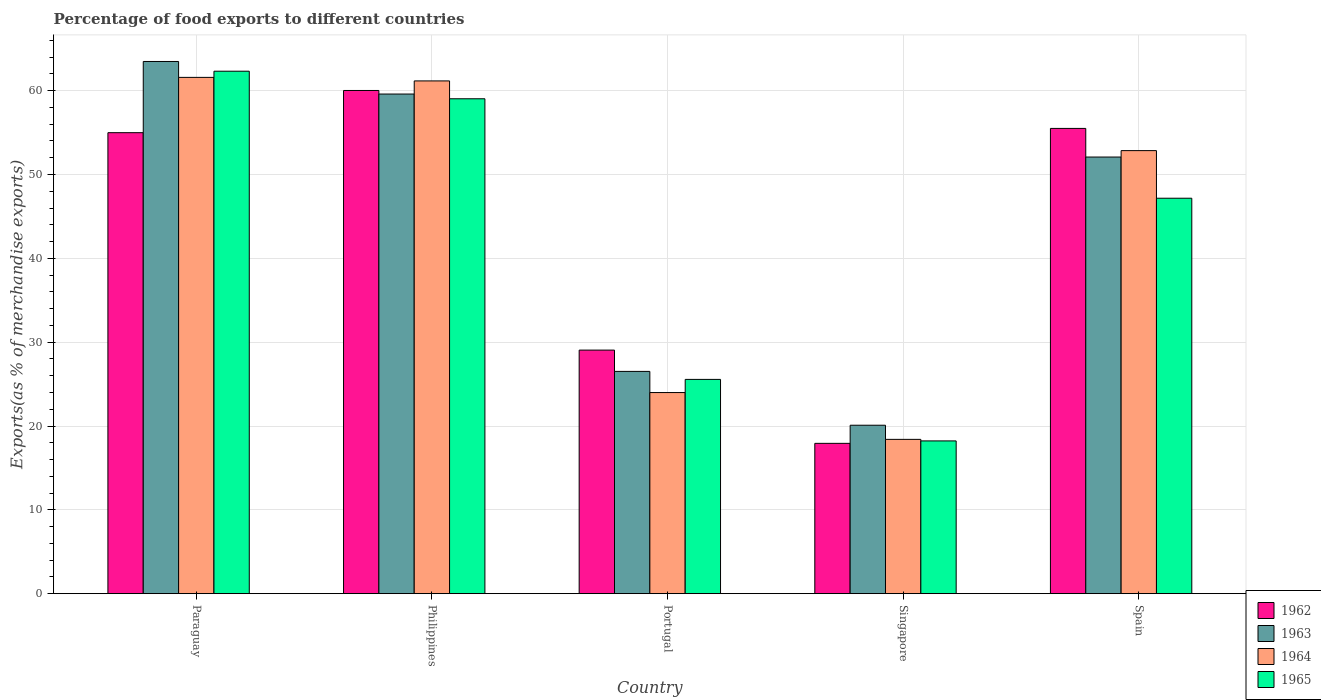How many different coloured bars are there?
Your answer should be compact. 4. How many groups of bars are there?
Give a very brief answer. 5. Are the number of bars per tick equal to the number of legend labels?
Your answer should be compact. Yes. Are the number of bars on each tick of the X-axis equal?
Offer a very short reply. Yes. What is the percentage of exports to different countries in 1965 in Philippines?
Your answer should be very brief. 59.04. Across all countries, what is the maximum percentage of exports to different countries in 1965?
Your answer should be compact. 62.32. Across all countries, what is the minimum percentage of exports to different countries in 1963?
Give a very brief answer. 20.09. In which country was the percentage of exports to different countries in 1965 maximum?
Provide a short and direct response. Paraguay. In which country was the percentage of exports to different countries in 1965 minimum?
Provide a succinct answer. Singapore. What is the total percentage of exports to different countries in 1963 in the graph?
Offer a terse response. 221.78. What is the difference between the percentage of exports to different countries in 1963 in Paraguay and that in Spain?
Offer a very short reply. 11.4. What is the difference between the percentage of exports to different countries in 1965 in Singapore and the percentage of exports to different countries in 1963 in Portugal?
Your answer should be very brief. -8.29. What is the average percentage of exports to different countries in 1965 per country?
Give a very brief answer. 42.46. What is the difference between the percentage of exports to different countries of/in 1965 and percentage of exports to different countries of/in 1964 in Philippines?
Make the answer very short. -2.13. What is the ratio of the percentage of exports to different countries in 1963 in Portugal to that in Singapore?
Your response must be concise. 1.32. What is the difference between the highest and the second highest percentage of exports to different countries in 1963?
Ensure brevity in your answer.  7.52. What is the difference between the highest and the lowest percentage of exports to different countries in 1962?
Give a very brief answer. 42.1. In how many countries, is the percentage of exports to different countries in 1962 greater than the average percentage of exports to different countries in 1962 taken over all countries?
Provide a succinct answer. 3. Is the sum of the percentage of exports to different countries in 1962 in Philippines and Singapore greater than the maximum percentage of exports to different countries in 1963 across all countries?
Keep it short and to the point. Yes. Is it the case that in every country, the sum of the percentage of exports to different countries in 1963 and percentage of exports to different countries in 1962 is greater than the sum of percentage of exports to different countries in 1965 and percentage of exports to different countries in 1964?
Provide a succinct answer. No. What does the 3rd bar from the left in Singapore represents?
Provide a short and direct response. 1964. What does the 3rd bar from the right in Philippines represents?
Offer a very short reply. 1963. How many countries are there in the graph?
Your response must be concise. 5. What is the difference between two consecutive major ticks on the Y-axis?
Offer a very short reply. 10. Are the values on the major ticks of Y-axis written in scientific E-notation?
Make the answer very short. No. Does the graph contain grids?
Make the answer very short. Yes. What is the title of the graph?
Your answer should be compact. Percentage of food exports to different countries. What is the label or title of the Y-axis?
Offer a terse response. Exports(as % of merchandise exports). What is the Exports(as % of merchandise exports) of 1962 in Paraguay?
Offer a very short reply. 54.99. What is the Exports(as % of merchandise exports) in 1963 in Paraguay?
Ensure brevity in your answer.  63.48. What is the Exports(as % of merchandise exports) of 1964 in Paraguay?
Keep it short and to the point. 61.59. What is the Exports(as % of merchandise exports) in 1965 in Paraguay?
Your answer should be compact. 62.32. What is the Exports(as % of merchandise exports) in 1962 in Philippines?
Provide a succinct answer. 60.03. What is the Exports(as % of merchandise exports) of 1963 in Philippines?
Provide a succinct answer. 59.6. What is the Exports(as % of merchandise exports) of 1964 in Philippines?
Provide a short and direct response. 61.17. What is the Exports(as % of merchandise exports) of 1965 in Philippines?
Offer a terse response. 59.04. What is the Exports(as % of merchandise exports) of 1962 in Portugal?
Provide a succinct answer. 29.05. What is the Exports(as % of merchandise exports) in 1963 in Portugal?
Ensure brevity in your answer.  26.51. What is the Exports(as % of merchandise exports) of 1964 in Portugal?
Provide a succinct answer. 23.99. What is the Exports(as % of merchandise exports) of 1965 in Portugal?
Make the answer very short. 25.56. What is the Exports(as % of merchandise exports) of 1962 in Singapore?
Give a very brief answer. 17.93. What is the Exports(as % of merchandise exports) of 1963 in Singapore?
Provide a short and direct response. 20.09. What is the Exports(as % of merchandise exports) in 1964 in Singapore?
Your answer should be compact. 18.41. What is the Exports(as % of merchandise exports) of 1965 in Singapore?
Your answer should be very brief. 18.22. What is the Exports(as % of merchandise exports) in 1962 in Spain?
Your answer should be very brief. 55.5. What is the Exports(as % of merchandise exports) in 1963 in Spain?
Your answer should be very brief. 52.09. What is the Exports(as % of merchandise exports) of 1964 in Spain?
Keep it short and to the point. 52.85. What is the Exports(as % of merchandise exports) of 1965 in Spain?
Offer a very short reply. 47.17. Across all countries, what is the maximum Exports(as % of merchandise exports) of 1962?
Your response must be concise. 60.03. Across all countries, what is the maximum Exports(as % of merchandise exports) in 1963?
Your answer should be compact. 63.48. Across all countries, what is the maximum Exports(as % of merchandise exports) in 1964?
Offer a terse response. 61.59. Across all countries, what is the maximum Exports(as % of merchandise exports) in 1965?
Make the answer very short. 62.32. Across all countries, what is the minimum Exports(as % of merchandise exports) of 1962?
Your answer should be compact. 17.93. Across all countries, what is the minimum Exports(as % of merchandise exports) of 1963?
Make the answer very short. 20.09. Across all countries, what is the minimum Exports(as % of merchandise exports) of 1964?
Make the answer very short. 18.41. Across all countries, what is the minimum Exports(as % of merchandise exports) in 1965?
Give a very brief answer. 18.22. What is the total Exports(as % of merchandise exports) of 1962 in the graph?
Give a very brief answer. 217.5. What is the total Exports(as % of merchandise exports) of 1963 in the graph?
Give a very brief answer. 221.78. What is the total Exports(as % of merchandise exports) of 1964 in the graph?
Provide a succinct answer. 218. What is the total Exports(as % of merchandise exports) of 1965 in the graph?
Provide a short and direct response. 212.31. What is the difference between the Exports(as % of merchandise exports) in 1962 in Paraguay and that in Philippines?
Provide a succinct answer. -5.03. What is the difference between the Exports(as % of merchandise exports) in 1963 in Paraguay and that in Philippines?
Provide a short and direct response. 3.88. What is the difference between the Exports(as % of merchandise exports) in 1964 in Paraguay and that in Philippines?
Your answer should be very brief. 0.42. What is the difference between the Exports(as % of merchandise exports) in 1965 in Paraguay and that in Philippines?
Offer a terse response. 3.29. What is the difference between the Exports(as % of merchandise exports) of 1962 in Paraguay and that in Portugal?
Your answer should be very brief. 25.94. What is the difference between the Exports(as % of merchandise exports) of 1963 in Paraguay and that in Portugal?
Ensure brevity in your answer.  36.97. What is the difference between the Exports(as % of merchandise exports) in 1964 in Paraguay and that in Portugal?
Provide a short and direct response. 37.6. What is the difference between the Exports(as % of merchandise exports) in 1965 in Paraguay and that in Portugal?
Give a very brief answer. 36.77. What is the difference between the Exports(as % of merchandise exports) of 1962 in Paraguay and that in Singapore?
Offer a very short reply. 37.06. What is the difference between the Exports(as % of merchandise exports) in 1963 in Paraguay and that in Singapore?
Offer a very short reply. 43.39. What is the difference between the Exports(as % of merchandise exports) in 1964 in Paraguay and that in Singapore?
Provide a succinct answer. 43.18. What is the difference between the Exports(as % of merchandise exports) in 1965 in Paraguay and that in Singapore?
Offer a very short reply. 44.1. What is the difference between the Exports(as % of merchandise exports) of 1962 in Paraguay and that in Spain?
Make the answer very short. -0.51. What is the difference between the Exports(as % of merchandise exports) of 1963 in Paraguay and that in Spain?
Your response must be concise. 11.4. What is the difference between the Exports(as % of merchandise exports) of 1964 in Paraguay and that in Spain?
Provide a short and direct response. 8.73. What is the difference between the Exports(as % of merchandise exports) of 1965 in Paraguay and that in Spain?
Ensure brevity in your answer.  15.15. What is the difference between the Exports(as % of merchandise exports) in 1962 in Philippines and that in Portugal?
Make the answer very short. 30.97. What is the difference between the Exports(as % of merchandise exports) of 1963 in Philippines and that in Portugal?
Ensure brevity in your answer.  33.09. What is the difference between the Exports(as % of merchandise exports) of 1964 in Philippines and that in Portugal?
Offer a terse response. 37.18. What is the difference between the Exports(as % of merchandise exports) in 1965 in Philippines and that in Portugal?
Provide a short and direct response. 33.48. What is the difference between the Exports(as % of merchandise exports) of 1962 in Philippines and that in Singapore?
Your answer should be very brief. 42.1. What is the difference between the Exports(as % of merchandise exports) in 1963 in Philippines and that in Singapore?
Your response must be concise. 39.51. What is the difference between the Exports(as % of merchandise exports) in 1964 in Philippines and that in Singapore?
Provide a succinct answer. 42.76. What is the difference between the Exports(as % of merchandise exports) of 1965 in Philippines and that in Singapore?
Provide a short and direct response. 40.81. What is the difference between the Exports(as % of merchandise exports) in 1962 in Philippines and that in Spain?
Offer a terse response. 4.53. What is the difference between the Exports(as % of merchandise exports) of 1963 in Philippines and that in Spain?
Your answer should be very brief. 7.52. What is the difference between the Exports(as % of merchandise exports) in 1964 in Philippines and that in Spain?
Keep it short and to the point. 8.31. What is the difference between the Exports(as % of merchandise exports) in 1965 in Philippines and that in Spain?
Ensure brevity in your answer.  11.86. What is the difference between the Exports(as % of merchandise exports) in 1962 in Portugal and that in Singapore?
Offer a terse response. 11.12. What is the difference between the Exports(as % of merchandise exports) of 1963 in Portugal and that in Singapore?
Provide a short and direct response. 6.42. What is the difference between the Exports(as % of merchandise exports) in 1964 in Portugal and that in Singapore?
Give a very brief answer. 5.58. What is the difference between the Exports(as % of merchandise exports) in 1965 in Portugal and that in Singapore?
Provide a succinct answer. 7.34. What is the difference between the Exports(as % of merchandise exports) in 1962 in Portugal and that in Spain?
Your answer should be compact. -26.45. What is the difference between the Exports(as % of merchandise exports) of 1963 in Portugal and that in Spain?
Provide a short and direct response. -25.57. What is the difference between the Exports(as % of merchandise exports) in 1964 in Portugal and that in Spain?
Ensure brevity in your answer.  -28.86. What is the difference between the Exports(as % of merchandise exports) in 1965 in Portugal and that in Spain?
Keep it short and to the point. -21.61. What is the difference between the Exports(as % of merchandise exports) of 1962 in Singapore and that in Spain?
Your answer should be compact. -37.57. What is the difference between the Exports(as % of merchandise exports) in 1963 in Singapore and that in Spain?
Your response must be concise. -31.99. What is the difference between the Exports(as % of merchandise exports) of 1964 in Singapore and that in Spain?
Offer a terse response. -34.45. What is the difference between the Exports(as % of merchandise exports) of 1965 in Singapore and that in Spain?
Provide a short and direct response. -28.95. What is the difference between the Exports(as % of merchandise exports) of 1962 in Paraguay and the Exports(as % of merchandise exports) of 1963 in Philippines?
Offer a very short reply. -4.61. What is the difference between the Exports(as % of merchandise exports) in 1962 in Paraguay and the Exports(as % of merchandise exports) in 1964 in Philippines?
Offer a very short reply. -6.18. What is the difference between the Exports(as % of merchandise exports) in 1962 in Paraguay and the Exports(as % of merchandise exports) in 1965 in Philippines?
Ensure brevity in your answer.  -4.04. What is the difference between the Exports(as % of merchandise exports) in 1963 in Paraguay and the Exports(as % of merchandise exports) in 1964 in Philippines?
Provide a succinct answer. 2.32. What is the difference between the Exports(as % of merchandise exports) in 1963 in Paraguay and the Exports(as % of merchandise exports) in 1965 in Philippines?
Ensure brevity in your answer.  4.45. What is the difference between the Exports(as % of merchandise exports) of 1964 in Paraguay and the Exports(as % of merchandise exports) of 1965 in Philippines?
Your answer should be compact. 2.55. What is the difference between the Exports(as % of merchandise exports) in 1962 in Paraguay and the Exports(as % of merchandise exports) in 1963 in Portugal?
Offer a very short reply. 28.48. What is the difference between the Exports(as % of merchandise exports) in 1962 in Paraguay and the Exports(as % of merchandise exports) in 1964 in Portugal?
Your answer should be very brief. 31. What is the difference between the Exports(as % of merchandise exports) in 1962 in Paraguay and the Exports(as % of merchandise exports) in 1965 in Portugal?
Keep it short and to the point. 29.43. What is the difference between the Exports(as % of merchandise exports) of 1963 in Paraguay and the Exports(as % of merchandise exports) of 1964 in Portugal?
Make the answer very short. 39.49. What is the difference between the Exports(as % of merchandise exports) of 1963 in Paraguay and the Exports(as % of merchandise exports) of 1965 in Portugal?
Provide a succinct answer. 37.93. What is the difference between the Exports(as % of merchandise exports) in 1964 in Paraguay and the Exports(as % of merchandise exports) in 1965 in Portugal?
Your answer should be compact. 36.03. What is the difference between the Exports(as % of merchandise exports) of 1962 in Paraguay and the Exports(as % of merchandise exports) of 1963 in Singapore?
Offer a terse response. 34.9. What is the difference between the Exports(as % of merchandise exports) in 1962 in Paraguay and the Exports(as % of merchandise exports) in 1964 in Singapore?
Provide a short and direct response. 36.59. What is the difference between the Exports(as % of merchandise exports) in 1962 in Paraguay and the Exports(as % of merchandise exports) in 1965 in Singapore?
Provide a short and direct response. 36.77. What is the difference between the Exports(as % of merchandise exports) of 1963 in Paraguay and the Exports(as % of merchandise exports) of 1964 in Singapore?
Your answer should be compact. 45.08. What is the difference between the Exports(as % of merchandise exports) of 1963 in Paraguay and the Exports(as % of merchandise exports) of 1965 in Singapore?
Offer a terse response. 45.26. What is the difference between the Exports(as % of merchandise exports) in 1964 in Paraguay and the Exports(as % of merchandise exports) in 1965 in Singapore?
Provide a short and direct response. 43.37. What is the difference between the Exports(as % of merchandise exports) in 1962 in Paraguay and the Exports(as % of merchandise exports) in 1963 in Spain?
Your answer should be very brief. 2.91. What is the difference between the Exports(as % of merchandise exports) of 1962 in Paraguay and the Exports(as % of merchandise exports) of 1964 in Spain?
Offer a very short reply. 2.14. What is the difference between the Exports(as % of merchandise exports) of 1962 in Paraguay and the Exports(as % of merchandise exports) of 1965 in Spain?
Keep it short and to the point. 7.82. What is the difference between the Exports(as % of merchandise exports) of 1963 in Paraguay and the Exports(as % of merchandise exports) of 1964 in Spain?
Keep it short and to the point. 10.63. What is the difference between the Exports(as % of merchandise exports) in 1963 in Paraguay and the Exports(as % of merchandise exports) in 1965 in Spain?
Give a very brief answer. 16.31. What is the difference between the Exports(as % of merchandise exports) of 1964 in Paraguay and the Exports(as % of merchandise exports) of 1965 in Spain?
Provide a short and direct response. 14.41. What is the difference between the Exports(as % of merchandise exports) in 1962 in Philippines and the Exports(as % of merchandise exports) in 1963 in Portugal?
Make the answer very short. 33.51. What is the difference between the Exports(as % of merchandise exports) of 1962 in Philippines and the Exports(as % of merchandise exports) of 1964 in Portugal?
Make the answer very short. 36.04. What is the difference between the Exports(as % of merchandise exports) of 1962 in Philippines and the Exports(as % of merchandise exports) of 1965 in Portugal?
Your answer should be very brief. 34.47. What is the difference between the Exports(as % of merchandise exports) in 1963 in Philippines and the Exports(as % of merchandise exports) in 1964 in Portugal?
Your response must be concise. 35.61. What is the difference between the Exports(as % of merchandise exports) in 1963 in Philippines and the Exports(as % of merchandise exports) in 1965 in Portugal?
Provide a succinct answer. 34.04. What is the difference between the Exports(as % of merchandise exports) of 1964 in Philippines and the Exports(as % of merchandise exports) of 1965 in Portugal?
Your answer should be compact. 35.61. What is the difference between the Exports(as % of merchandise exports) of 1962 in Philippines and the Exports(as % of merchandise exports) of 1963 in Singapore?
Give a very brief answer. 39.93. What is the difference between the Exports(as % of merchandise exports) in 1962 in Philippines and the Exports(as % of merchandise exports) in 1964 in Singapore?
Offer a terse response. 41.62. What is the difference between the Exports(as % of merchandise exports) in 1962 in Philippines and the Exports(as % of merchandise exports) in 1965 in Singapore?
Make the answer very short. 41.8. What is the difference between the Exports(as % of merchandise exports) of 1963 in Philippines and the Exports(as % of merchandise exports) of 1964 in Singapore?
Give a very brief answer. 41.2. What is the difference between the Exports(as % of merchandise exports) in 1963 in Philippines and the Exports(as % of merchandise exports) in 1965 in Singapore?
Ensure brevity in your answer.  41.38. What is the difference between the Exports(as % of merchandise exports) of 1964 in Philippines and the Exports(as % of merchandise exports) of 1965 in Singapore?
Your answer should be very brief. 42.95. What is the difference between the Exports(as % of merchandise exports) in 1962 in Philippines and the Exports(as % of merchandise exports) in 1963 in Spain?
Offer a very short reply. 7.94. What is the difference between the Exports(as % of merchandise exports) of 1962 in Philippines and the Exports(as % of merchandise exports) of 1964 in Spain?
Provide a succinct answer. 7.17. What is the difference between the Exports(as % of merchandise exports) of 1962 in Philippines and the Exports(as % of merchandise exports) of 1965 in Spain?
Keep it short and to the point. 12.85. What is the difference between the Exports(as % of merchandise exports) in 1963 in Philippines and the Exports(as % of merchandise exports) in 1964 in Spain?
Your response must be concise. 6.75. What is the difference between the Exports(as % of merchandise exports) of 1963 in Philippines and the Exports(as % of merchandise exports) of 1965 in Spain?
Your response must be concise. 12.43. What is the difference between the Exports(as % of merchandise exports) of 1964 in Philippines and the Exports(as % of merchandise exports) of 1965 in Spain?
Keep it short and to the point. 13.99. What is the difference between the Exports(as % of merchandise exports) of 1962 in Portugal and the Exports(as % of merchandise exports) of 1963 in Singapore?
Keep it short and to the point. 8.96. What is the difference between the Exports(as % of merchandise exports) in 1962 in Portugal and the Exports(as % of merchandise exports) in 1964 in Singapore?
Your answer should be compact. 10.65. What is the difference between the Exports(as % of merchandise exports) of 1962 in Portugal and the Exports(as % of merchandise exports) of 1965 in Singapore?
Provide a short and direct response. 10.83. What is the difference between the Exports(as % of merchandise exports) in 1963 in Portugal and the Exports(as % of merchandise exports) in 1964 in Singapore?
Keep it short and to the point. 8.11. What is the difference between the Exports(as % of merchandise exports) of 1963 in Portugal and the Exports(as % of merchandise exports) of 1965 in Singapore?
Offer a terse response. 8.29. What is the difference between the Exports(as % of merchandise exports) of 1964 in Portugal and the Exports(as % of merchandise exports) of 1965 in Singapore?
Make the answer very short. 5.77. What is the difference between the Exports(as % of merchandise exports) of 1962 in Portugal and the Exports(as % of merchandise exports) of 1963 in Spain?
Your answer should be very brief. -23.03. What is the difference between the Exports(as % of merchandise exports) in 1962 in Portugal and the Exports(as % of merchandise exports) in 1964 in Spain?
Offer a terse response. -23.8. What is the difference between the Exports(as % of merchandise exports) in 1962 in Portugal and the Exports(as % of merchandise exports) in 1965 in Spain?
Your answer should be very brief. -18.12. What is the difference between the Exports(as % of merchandise exports) of 1963 in Portugal and the Exports(as % of merchandise exports) of 1964 in Spain?
Your response must be concise. -26.34. What is the difference between the Exports(as % of merchandise exports) in 1963 in Portugal and the Exports(as % of merchandise exports) in 1965 in Spain?
Your answer should be very brief. -20.66. What is the difference between the Exports(as % of merchandise exports) of 1964 in Portugal and the Exports(as % of merchandise exports) of 1965 in Spain?
Provide a succinct answer. -23.18. What is the difference between the Exports(as % of merchandise exports) in 1962 in Singapore and the Exports(as % of merchandise exports) in 1963 in Spain?
Provide a short and direct response. -34.16. What is the difference between the Exports(as % of merchandise exports) of 1962 in Singapore and the Exports(as % of merchandise exports) of 1964 in Spain?
Provide a succinct answer. -34.92. What is the difference between the Exports(as % of merchandise exports) of 1962 in Singapore and the Exports(as % of merchandise exports) of 1965 in Spain?
Make the answer very short. -29.24. What is the difference between the Exports(as % of merchandise exports) of 1963 in Singapore and the Exports(as % of merchandise exports) of 1964 in Spain?
Your answer should be very brief. -32.76. What is the difference between the Exports(as % of merchandise exports) of 1963 in Singapore and the Exports(as % of merchandise exports) of 1965 in Spain?
Offer a very short reply. -27.08. What is the difference between the Exports(as % of merchandise exports) of 1964 in Singapore and the Exports(as % of merchandise exports) of 1965 in Spain?
Provide a short and direct response. -28.77. What is the average Exports(as % of merchandise exports) in 1962 per country?
Provide a short and direct response. 43.5. What is the average Exports(as % of merchandise exports) in 1963 per country?
Keep it short and to the point. 44.36. What is the average Exports(as % of merchandise exports) of 1964 per country?
Provide a short and direct response. 43.6. What is the average Exports(as % of merchandise exports) in 1965 per country?
Provide a succinct answer. 42.46. What is the difference between the Exports(as % of merchandise exports) in 1962 and Exports(as % of merchandise exports) in 1963 in Paraguay?
Ensure brevity in your answer.  -8.49. What is the difference between the Exports(as % of merchandise exports) in 1962 and Exports(as % of merchandise exports) in 1964 in Paraguay?
Ensure brevity in your answer.  -6.6. What is the difference between the Exports(as % of merchandise exports) in 1962 and Exports(as % of merchandise exports) in 1965 in Paraguay?
Your answer should be very brief. -7.33. What is the difference between the Exports(as % of merchandise exports) in 1963 and Exports(as % of merchandise exports) in 1964 in Paraguay?
Offer a very short reply. 1.9. What is the difference between the Exports(as % of merchandise exports) in 1963 and Exports(as % of merchandise exports) in 1965 in Paraguay?
Your answer should be compact. 1.16. What is the difference between the Exports(as % of merchandise exports) in 1964 and Exports(as % of merchandise exports) in 1965 in Paraguay?
Ensure brevity in your answer.  -0.74. What is the difference between the Exports(as % of merchandise exports) in 1962 and Exports(as % of merchandise exports) in 1963 in Philippines?
Offer a very short reply. 0.42. What is the difference between the Exports(as % of merchandise exports) in 1962 and Exports(as % of merchandise exports) in 1964 in Philippines?
Your response must be concise. -1.14. What is the difference between the Exports(as % of merchandise exports) in 1963 and Exports(as % of merchandise exports) in 1964 in Philippines?
Keep it short and to the point. -1.57. What is the difference between the Exports(as % of merchandise exports) in 1963 and Exports(as % of merchandise exports) in 1965 in Philippines?
Your response must be concise. 0.57. What is the difference between the Exports(as % of merchandise exports) in 1964 and Exports(as % of merchandise exports) in 1965 in Philippines?
Give a very brief answer. 2.13. What is the difference between the Exports(as % of merchandise exports) in 1962 and Exports(as % of merchandise exports) in 1963 in Portugal?
Offer a very short reply. 2.54. What is the difference between the Exports(as % of merchandise exports) in 1962 and Exports(as % of merchandise exports) in 1964 in Portugal?
Your answer should be very brief. 5.06. What is the difference between the Exports(as % of merchandise exports) of 1962 and Exports(as % of merchandise exports) of 1965 in Portugal?
Your answer should be very brief. 3.49. What is the difference between the Exports(as % of merchandise exports) of 1963 and Exports(as % of merchandise exports) of 1964 in Portugal?
Your response must be concise. 2.52. What is the difference between the Exports(as % of merchandise exports) in 1963 and Exports(as % of merchandise exports) in 1965 in Portugal?
Provide a short and direct response. 0.95. What is the difference between the Exports(as % of merchandise exports) of 1964 and Exports(as % of merchandise exports) of 1965 in Portugal?
Keep it short and to the point. -1.57. What is the difference between the Exports(as % of merchandise exports) in 1962 and Exports(as % of merchandise exports) in 1963 in Singapore?
Your answer should be compact. -2.16. What is the difference between the Exports(as % of merchandise exports) of 1962 and Exports(as % of merchandise exports) of 1964 in Singapore?
Offer a very short reply. -0.48. What is the difference between the Exports(as % of merchandise exports) of 1962 and Exports(as % of merchandise exports) of 1965 in Singapore?
Keep it short and to the point. -0.29. What is the difference between the Exports(as % of merchandise exports) of 1963 and Exports(as % of merchandise exports) of 1964 in Singapore?
Provide a succinct answer. 1.69. What is the difference between the Exports(as % of merchandise exports) in 1963 and Exports(as % of merchandise exports) in 1965 in Singapore?
Provide a short and direct response. 1.87. What is the difference between the Exports(as % of merchandise exports) in 1964 and Exports(as % of merchandise exports) in 1965 in Singapore?
Your response must be concise. 0.18. What is the difference between the Exports(as % of merchandise exports) in 1962 and Exports(as % of merchandise exports) in 1963 in Spain?
Make the answer very short. 3.42. What is the difference between the Exports(as % of merchandise exports) in 1962 and Exports(as % of merchandise exports) in 1964 in Spain?
Your response must be concise. 2.65. What is the difference between the Exports(as % of merchandise exports) in 1962 and Exports(as % of merchandise exports) in 1965 in Spain?
Keep it short and to the point. 8.33. What is the difference between the Exports(as % of merchandise exports) of 1963 and Exports(as % of merchandise exports) of 1964 in Spain?
Provide a short and direct response. -0.77. What is the difference between the Exports(as % of merchandise exports) in 1963 and Exports(as % of merchandise exports) in 1965 in Spain?
Offer a very short reply. 4.91. What is the difference between the Exports(as % of merchandise exports) in 1964 and Exports(as % of merchandise exports) in 1965 in Spain?
Your response must be concise. 5.68. What is the ratio of the Exports(as % of merchandise exports) in 1962 in Paraguay to that in Philippines?
Make the answer very short. 0.92. What is the ratio of the Exports(as % of merchandise exports) of 1963 in Paraguay to that in Philippines?
Your answer should be compact. 1.07. What is the ratio of the Exports(as % of merchandise exports) of 1965 in Paraguay to that in Philippines?
Your response must be concise. 1.06. What is the ratio of the Exports(as % of merchandise exports) of 1962 in Paraguay to that in Portugal?
Make the answer very short. 1.89. What is the ratio of the Exports(as % of merchandise exports) in 1963 in Paraguay to that in Portugal?
Offer a terse response. 2.39. What is the ratio of the Exports(as % of merchandise exports) of 1964 in Paraguay to that in Portugal?
Your response must be concise. 2.57. What is the ratio of the Exports(as % of merchandise exports) of 1965 in Paraguay to that in Portugal?
Give a very brief answer. 2.44. What is the ratio of the Exports(as % of merchandise exports) in 1962 in Paraguay to that in Singapore?
Offer a terse response. 3.07. What is the ratio of the Exports(as % of merchandise exports) in 1963 in Paraguay to that in Singapore?
Provide a succinct answer. 3.16. What is the ratio of the Exports(as % of merchandise exports) of 1964 in Paraguay to that in Singapore?
Give a very brief answer. 3.35. What is the ratio of the Exports(as % of merchandise exports) in 1965 in Paraguay to that in Singapore?
Your answer should be compact. 3.42. What is the ratio of the Exports(as % of merchandise exports) of 1962 in Paraguay to that in Spain?
Offer a terse response. 0.99. What is the ratio of the Exports(as % of merchandise exports) in 1963 in Paraguay to that in Spain?
Your answer should be very brief. 1.22. What is the ratio of the Exports(as % of merchandise exports) of 1964 in Paraguay to that in Spain?
Your answer should be very brief. 1.17. What is the ratio of the Exports(as % of merchandise exports) of 1965 in Paraguay to that in Spain?
Your answer should be very brief. 1.32. What is the ratio of the Exports(as % of merchandise exports) of 1962 in Philippines to that in Portugal?
Offer a very short reply. 2.07. What is the ratio of the Exports(as % of merchandise exports) in 1963 in Philippines to that in Portugal?
Make the answer very short. 2.25. What is the ratio of the Exports(as % of merchandise exports) of 1964 in Philippines to that in Portugal?
Offer a very short reply. 2.55. What is the ratio of the Exports(as % of merchandise exports) in 1965 in Philippines to that in Portugal?
Offer a very short reply. 2.31. What is the ratio of the Exports(as % of merchandise exports) in 1962 in Philippines to that in Singapore?
Ensure brevity in your answer.  3.35. What is the ratio of the Exports(as % of merchandise exports) in 1963 in Philippines to that in Singapore?
Keep it short and to the point. 2.97. What is the ratio of the Exports(as % of merchandise exports) of 1964 in Philippines to that in Singapore?
Keep it short and to the point. 3.32. What is the ratio of the Exports(as % of merchandise exports) of 1965 in Philippines to that in Singapore?
Your response must be concise. 3.24. What is the ratio of the Exports(as % of merchandise exports) of 1962 in Philippines to that in Spain?
Offer a terse response. 1.08. What is the ratio of the Exports(as % of merchandise exports) in 1963 in Philippines to that in Spain?
Make the answer very short. 1.14. What is the ratio of the Exports(as % of merchandise exports) in 1964 in Philippines to that in Spain?
Keep it short and to the point. 1.16. What is the ratio of the Exports(as % of merchandise exports) of 1965 in Philippines to that in Spain?
Your answer should be very brief. 1.25. What is the ratio of the Exports(as % of merchandise exports) in 1962 in Portugal to that in Singapore?
Your response must be concise. 1.62. What is the ratio of the Exports(as % of merchandise exports) in 1963 in Portugal to that in Singapore?
Your answer should be very brief. 1.32. What is the ratio of the Exports(as % of merchandise exports) of 1964 in Portugal to that in Singapore?
Offer a terse response. 1.3. What is the ratio of the Exports(as % of merchandise exports) in 1965 in Portugal to that in Singapore?
Provide a succinct answer. 1.4. What is the ratio of the Exports(as % of merchandise exports) of 1962 in Portugal to that in Spain?
Provide a succinct answer. 0.52. What is the ratio of the Exports(as % of merchandise exports) in 1963 in Portugal to that in Spain?
Provide a succinct answer. 0.51. What is the ratio of the Exports(as % of merchandise exports) in 1964 in Portugal to that in Spain?
Keep it short and to the point. 0.45. What is the ratio of the Exports(as % of merchandise exports) in 1965 in Portugal to that in Spain?
Provide a succinct answer. 0.54. What is the ratio of the Exports(as % of merchandise exports) of 1962 in Singapore to that in Spain?
Ensure brevity in your answer.  0.32. What is the ratio of the Exports(as % of merchandise exports) of 1963 in Singapore to that in Spain?
Provide a succinct answer. 0.39. What is the ratio of the Exports(as % of merchandise exports) of 1964 in Singapore to that in Spain?
Your answer should be compact. 0.35. What is the ratio of the Exports(as % of merchandise exports) of 1965 in Singapore to that in Spain?
Give a very brief answer. 0.39. What is the difference between the highest and the second highest Exports(as % of merchandise exports) in 1962?
Provide a short and direct response. 4.53. What is the difference between the highest and the second highest Exports(as % of merchandise exports) in 1963?
Give a very brief answer. 3.88. What is the difference between the highest and the second highest Exports(as % of merchandise exports) of 1964?
Make the answer very short. 0.42. What is the difference between the highest and the second highest Exports(as % of merchandise exports) in 1965?
Keep it short and to the point. 3.29. What is the difference between the highest and the lowest Exports(as % of merchandise exports) in 1962?
Your answer should be compact. 42.1. What is the difference between the highest and the lowest Exports(as % of merchandise exports) in 1963?
Your response must be concise. 43.39. What is the difference between the highest and the lowest Exports(as % of merchandise exports) in 1964?
Provide a short and direct response. 43.18. What is the difference between the highest and the lowest Exports(as % of merchandise exports) of 1965?
Offer a terse response. 44.1. 